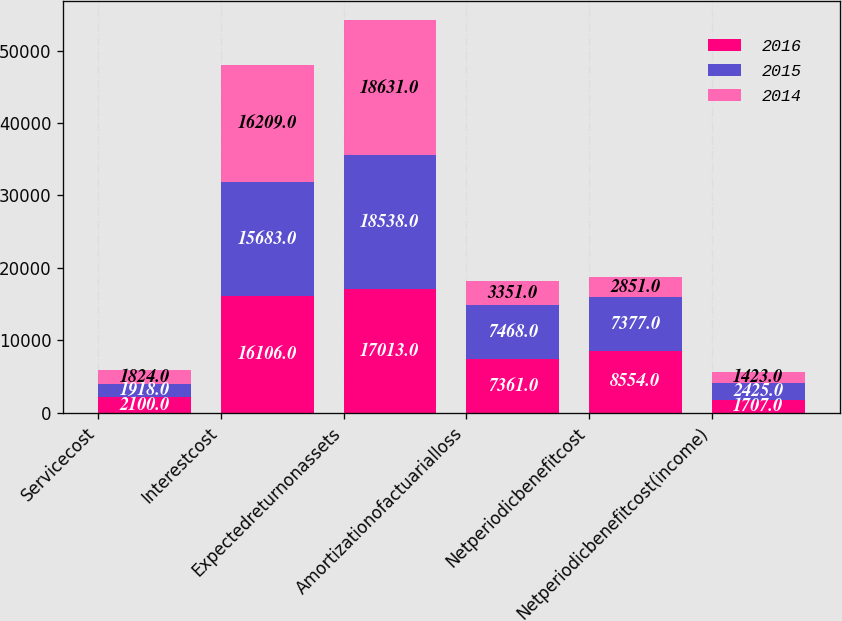<chart> <loc_0><loc_0><loc_500><loc_500><stacked_bar_chart><ecel><fcel>Servicecost<fcel>Interestcost<fcel>Expectedreturnonassets<fcel>Amortizationofactuarialloss<fcel>Netperiodicbenefitcost<fcel>Netperiodicbenefitcost(income)<nl><fcel>2016<fcel>2100<fcel>16106<fcel>17013<fcel>7361<fcel>8554<fcel>1707<nl><fcel>2015<fcel>1918<fcel>15683<fcel>18538<fcel>7468<fcel>7377<fcel>2425<nl><fcel>2014<fcel>1824<fcel>16209<fcel>18631<fcel>3351<fcel>2851<fcel>1423<nl></chart> 